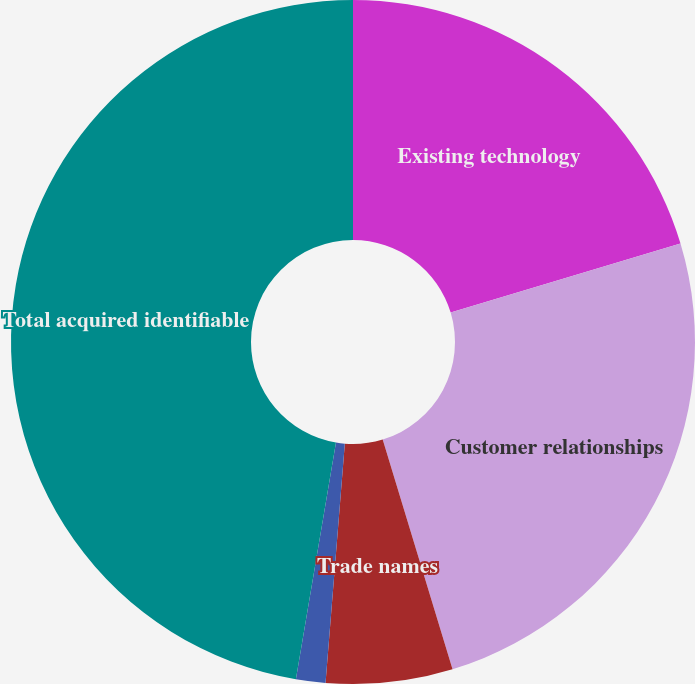Convert chart to OTSL. <chart><loc_0><loc_0><loc_500><loc_500><pie_chart><fcel>Existing technology<fcel>Customer relationships<fcel>Trade names<fcel>Patents and licenses<fcel>Total acquired identifiable<nl><fcel>20.35%<fcel>24.95%<fcel>5.98%<fcel>1.39%<fcel>47.33%<nl></chart> 